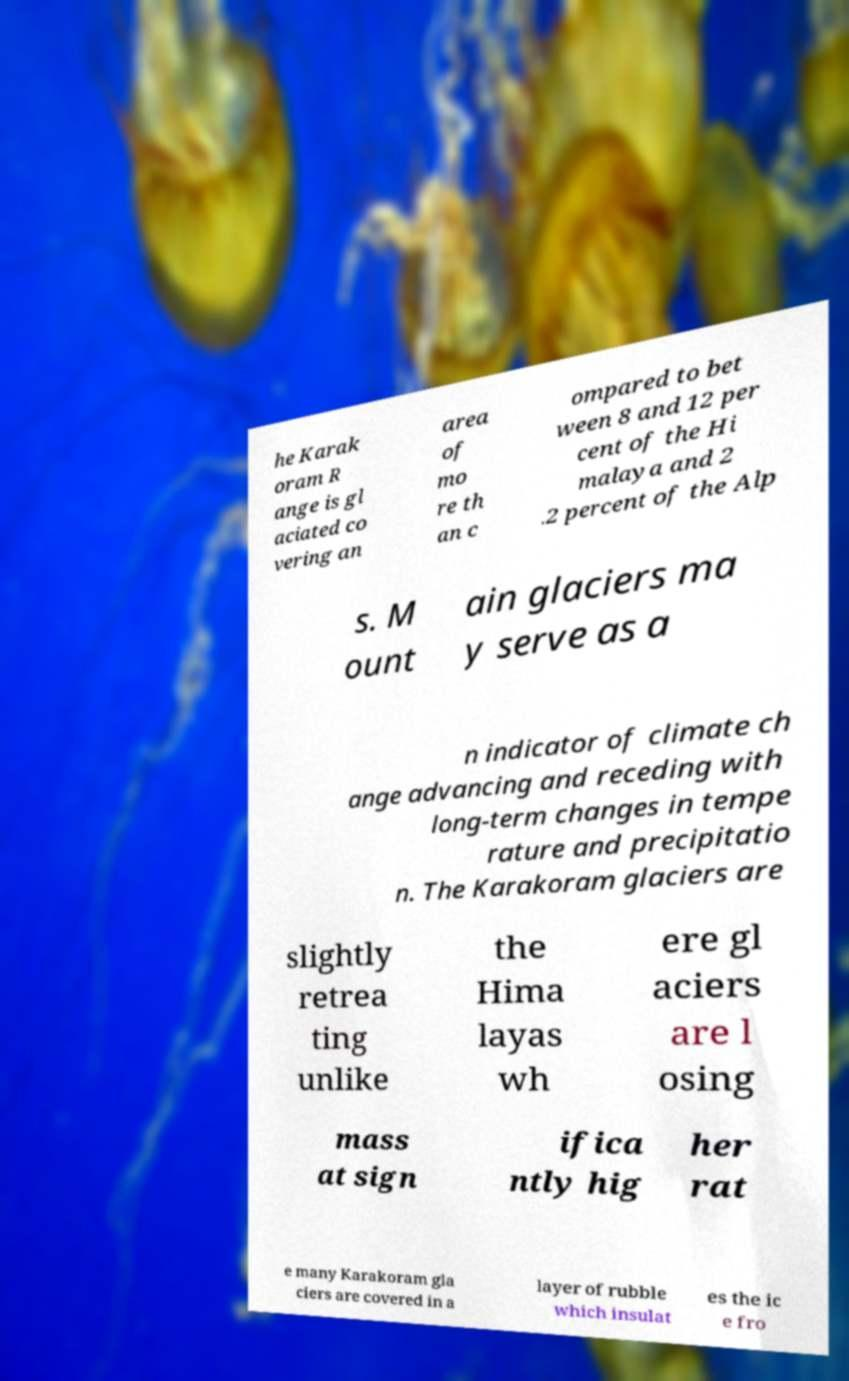Can you read and provide the text displayed in the image?This photo seems to have some interesting text. Can you extract and type it out for me? he Karak oram R ange is gl aciated co vering an area of mo re th an c ompared to bet ween 8 and 12 per cent of the Hi malaya and 2 .2 percent of the Alp s. M ount ain glaciers ma y serve as a n indicator of climate ch ange advancing and receding with long-term changes in tempe rature and precipitatio n. The Karakoram glaciers are slightly retrea ting unlike the Hima layas wh ere gl aciers are l osing mass at sign ifica ntly hig her rat e many Karakoram gla ciers are covered in a layer of rubble which insulat es the ic e fro 